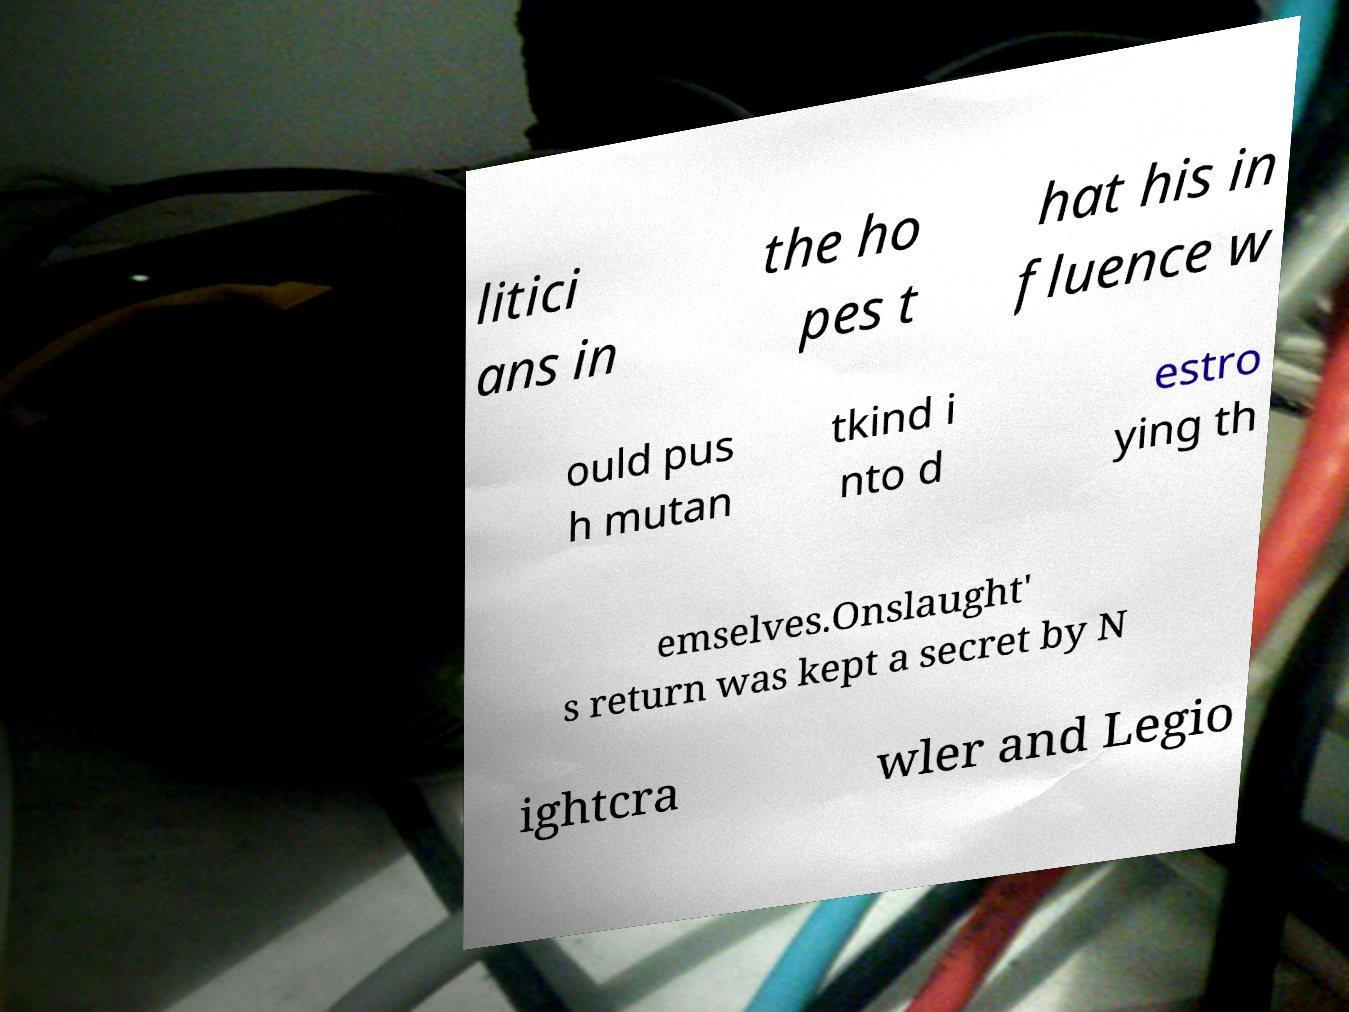Could you extract and type out the text from this image? litici ans in the ho pes t hat his in fluence w ould pus h mutan tkind i nto d estro ying th emselves.Onslaught' s return was kept a secret by N ightcra wler and Legio 